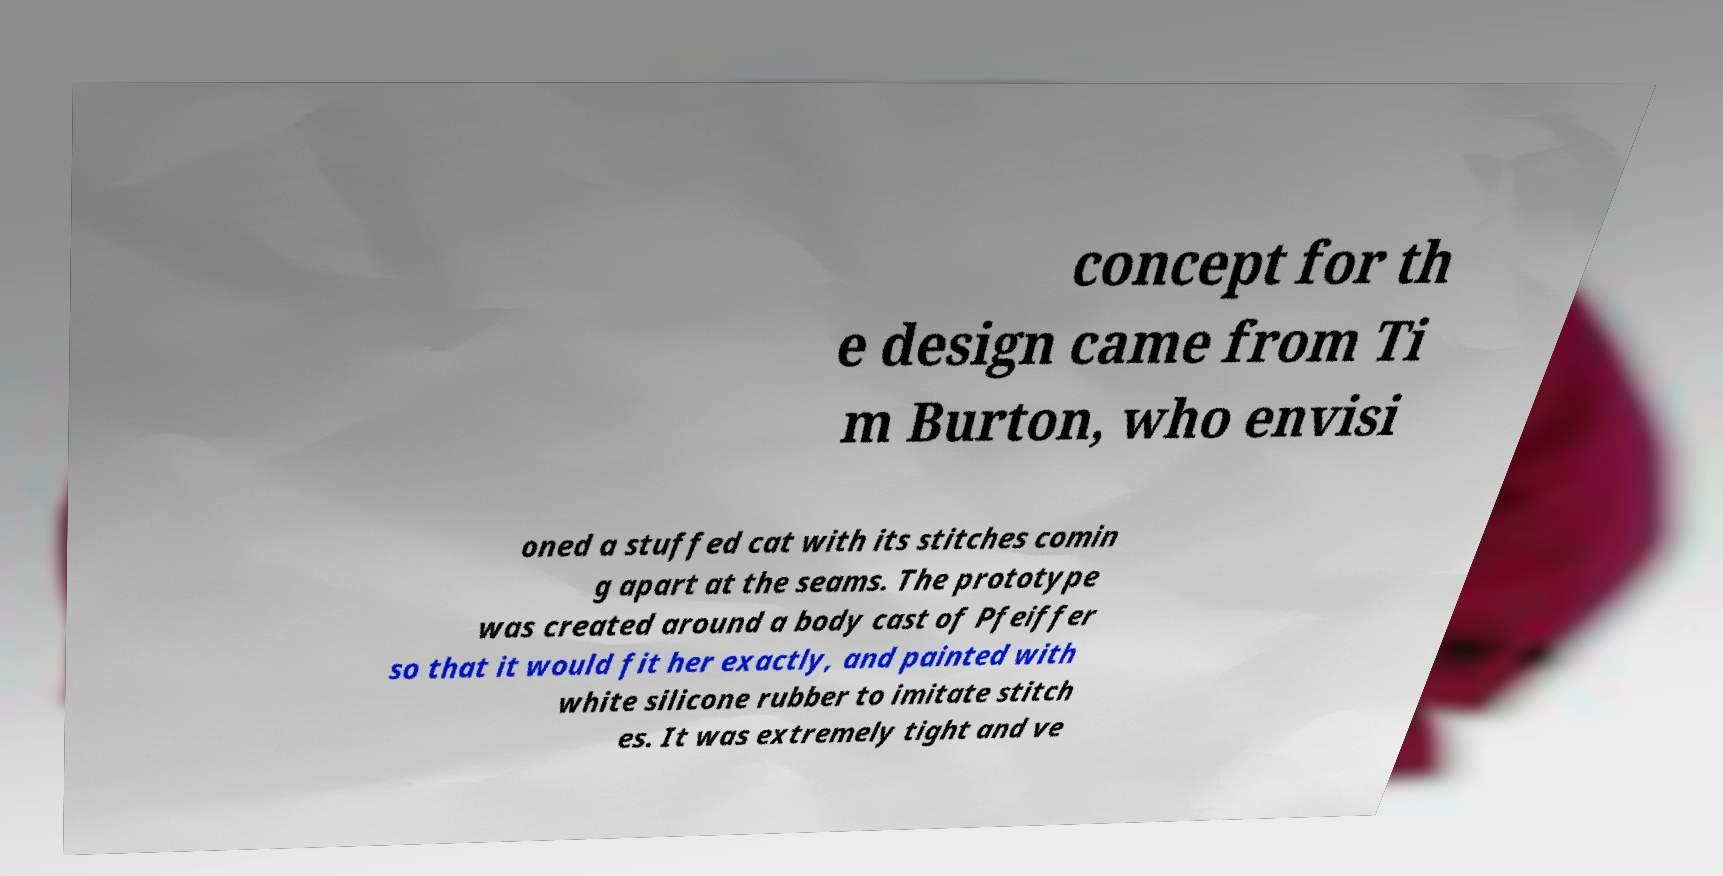For documentation purposes, I need the text within this image transcribed. Could you provide that? concept for th e design came from Ti m Burton, who envisi oned a stuffed cat with its stitches comin g apart at the seams. The prototype was created around a body cast of Pfeiffer so that it would fit her exactly, and painted with white silicone rubber to imitate stitch es. It was extremely tight and ve 